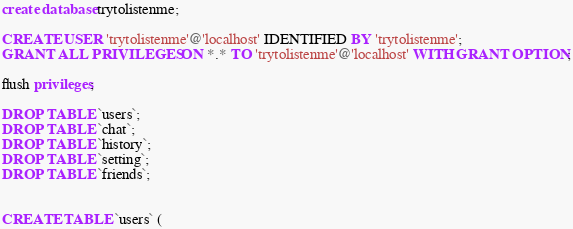<code> <loc_0><loc_0><loc_500><loc_500><_SQL_>create database trytolistenme;

CREATE USER 'trytolistenme'@'localhost' IDENTIFIED BY 'trytolistenme';
GRANT ALL PRIVILEGES ON *.* TO 'trytolistenme'@'localhost' WITH GRANT OPTION;

flush privileges;

DROP TABLE `users`;
DROP TABLE `chat`;
DROP TABLE `history`;
DROP TABLE `setting`;
DROP TABLE `friends`;


CREATE TABLE `users` (</code> 